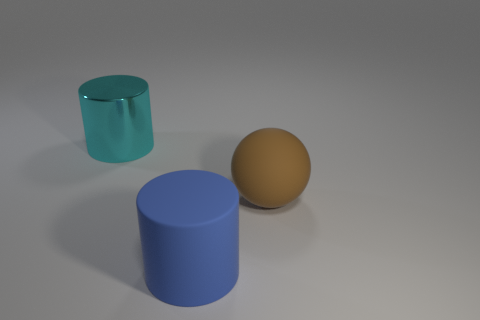Add 2 shiny objects. How many objects exist? 5 Subtract all balls. How many objects are left? 2 Subtract 0 yellow cubes. How many objects are left? 3 Subtract all big green cubes. Subtract all big cylinders. How many objects are left? 1 Add 2 big blue cylinders. How many big blue cylinders are left? 3 Add 3 big red cylinders. How many big red cylinders exist? 3 